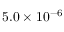<formula> <loc_0><loc_0><loc_500><loc_500>5 . 0 \times 1 0 ^ { - 6 }</formula> 